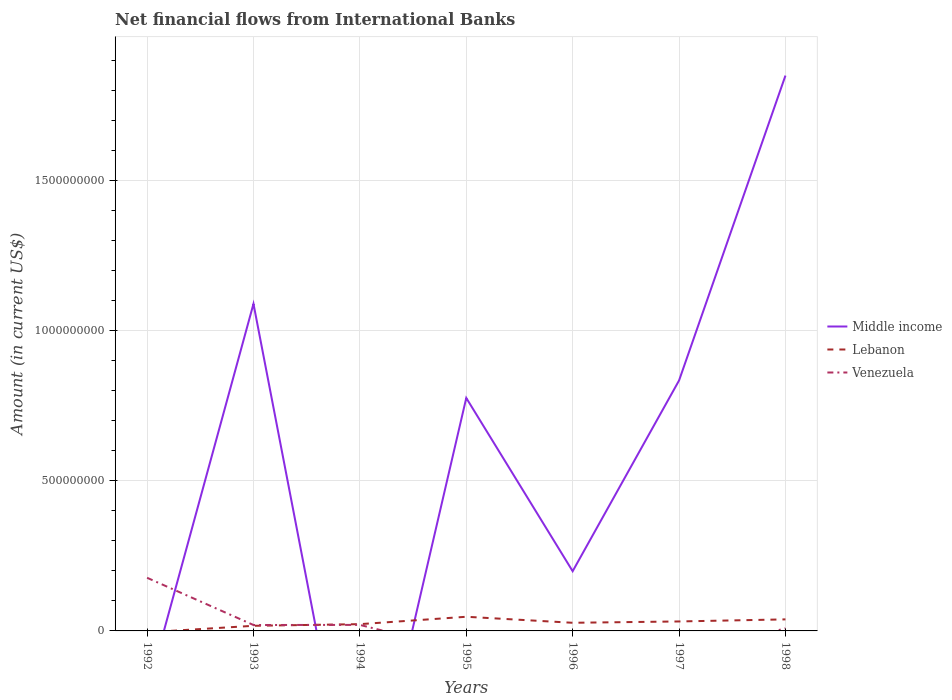Is the number of lines equal to the number of legend labels?
Make the answer very short. No. What is the total net financial aid flows in Venezuela in the graph?
Provide a short and direct response. -4.05e+05. What is the difference between the highest and the second highest net financial aid flows in Middle income?
Provide a short and direct response. 1.85e+09. Does the graph contain grids?
Make the answer very short. Yes. How many legend labels are there?
Provide a succinct answer. 3. How are the legend labels stacked?
Provide a short and direct response. Vertical. What is the title of the graph?
Your answer should be compact. Net financial flows from International Banks. Does "Djibouti" appear as one of the legend labels in the graph?
Offer a terse response. No. What is the label or title of the X-axis?
Make the answer very short. Years. What is the label or title of the Y-axis?
Your response must be concise. Amount (in current US$). What is the Amount (in current US$) in Venezuela in 1992?
Keep it short and to the point. 1.77e+08. What is the Amount (in current US$) of Middle income in 1993?
Make the answer very short. 1.09e+09. What is the Amount (in current US$) of Lebanon in 1993?
Your response must be concise. 1.70e+07. What is the Amount (in current US$) in Venezuela in 1993?
Keep it short and to the point. 1.97e+07. What is the Amount (in current US$) in Lebanon in 1994?
Your response must be concise. 2.25e+07. What is the Amount (in current US$) in Venezuela in 1994?
Provide a succinct answer. 2.01e+07. What is the Amount (in current US$) of Middle income in 1995?
Give a very brief answer. 7.75e+08. What is the Amount (in current US$) of Lebanon in 1995?
Provide a short and direct response. 4.71e+07. What is the Amount (in current US$) in Middle income in 1996?
Keep it short and to the point. 1.99e+08. What is the Amount (in current US$) of Lebanon in 1996?
Offer a very short reply. 2.71e+07. What is the Amount (in current US$) in Venezuela in 1996?
Keep it short and to the point. 0. What is the Amount (in current US$) in Middle income in 1997?
Your answer should be compact. 8.34e+08. What is the Amount (in current US$) of Lebanon in 1997?
Offer a terse response. 3.15e+07. What is the Amount (in current US$) of Middle income in 1998?
Provide a succinct answer. 1.85e+09. What is the Amount (in current US$) of Lebanon in 1998?
Provide a short and direct response. 3.84e+07. What is the Amount (in current US$) of Venezuela in 1998?
Your response must be concise. 8.53e+06. Across all years, what is the maximum Amount (in current US$) of Middle income?
Your answer should be very brief. 1.85e+09. Across all years, what is the maximum Amount (in current US$) of Lebanon?
Offer a very short reply. 4.71e+07. Across all years, what is the maximum Amount (in current US$) of Venezuela?
Provide a succinct answer. 1.77e+08. Across all years, what is the minimum Amount (in current US$) in Lebanon?
Offer a very short reply. 0. Across all years, what is the minimum Amount (in current US$) in Venezuela?
Provide a short and direct response. 0. What is the total Amount (in current US$) of Middle income in the graph?
Provide a succinct answer. 4.74e+09. What is the total Amount (in current US$) in Lebanon in the graph?
Make the answer very short. 1.84e+08. What is the total Amount (in current US$) of Venezuela in the graph?
Your answer should be very brief. 2.25e+08. What is the difference between the Amount (in current US$) of Venezuela in 1992 and that in 1993?
Keep it short and to the point. 1.57e+08. What is the difference between the Amount (in current US$) in Venezuela in 1992 and that in 1994?
Your answer should be compact. 1.57e+08. What is the difference between the Amount (in current US$) of Venezuela in 1992 and that in 1998?
Your answer should be very brief. 1.68e+08. What is the difference between the Amount (in current US$) of Lebanon in 1993 and that in 1994?
Provide a short and direct response. -5.49e+06. What is the difference between the Amount (in current US$) in Venezuela in 1993 and that in 1994?
Your answer should be compact. -4.05e+05. What is the difference between the Amount (in current US$) of Middle income in 1993 and that in 1995?
Offer a very short reply. 3.13e+08. What is the difference between the Amount (in current US$) of Lebanon in 1993 and that in 1995?
Your answer should be compact. -3.01e+07. What is the difference between the Amount (in current US$) in Middle income in 1993 and that in 1996?
Your response must be concise. 8.90e+08. What is the difference between the Amount (in current US$) in Lebanon in 1993 and that in 1996?
Ensure brevity in your answer.  -1.00e+07. What is the difference between the Amount (in current US$) of Middle income in 1993 and that in 1997?
Offer a terse response. 2.55e+08. What is the difference between the Amount (in current US$) of Lebanon in 1993 and that in 1997?
Provide a succinct answer. -1.45e+07. What is the difference between the Amount (in current US$) in Middle income in 1993 and that in 1998?
Your answer should be very brief. -7.60e+08. What is the difference between the Amount (in current US$) of Lebanon in 1993 and that in 1998?
Make the answer very short. -2.14e+07. What is the difference between the Amount (in current US$) of Venezuela in 1993 and that in 1998?
Your response must be concise. 1.11e+07. What is the difference between the Amount (in current US$) of Lebanon in 1994 and that in 1995?
Offer a very short reply. -2.46e+07. What is the difference between the Amount (in current US$) of Lebanon in 1994 and that in 1996?
Provide a succinct answer. -4.54e+06. What is the difference between the Amount (in current US$) of Lebanon in 1994 and that in 1997?
Ensure brevity in your answer.  -8.98e+06. What is the difference between the Amount (in current US$) in Lebanon in 1994 and that in 1998?
Offer a terse response. -1.59e+07. What is the difference between the Amount (in current US$) of Venezuela in 1994 and that in 1998?
Offer a terse response. 1.15e+07. What is the difference between the Amount (in current US$) in Middle income in 1995 and that in 1996?
Keep it short and to the point. 5.77e+08. What is the difference between the Amount (in current US$) of Lebanon in 1995 and that in 1996?
Offer a terse response. 2.00e+07. What is the difference between the Amount (in current US$) of Middle income in 1995 and that in 1997?
Ensure brevity in your answer.  -5.82e+07. What is the difference between the Amount (in current US$) of Lebanon in 1995 and that in 1997?
Your response must be concise. 1.56e+07. What is the difference between the Amount (in current US$) in Middle income in 1995 and that in 1998?
Offer a very short reply. -1.07e+09. What is the difference between the Amount (in current US$) of Lebanon in 1995 and that in 1998?
Make the answer very short. 8.68e+06. What is the difference between the Amount (in current US$) of Middle income in 1996 and that in 1997?
Provide a succinct answer. -6.35e+08. What is the difference between the Amount (in current US$) in Lebanon in 1996 and that in 1997?
Your answer should be compact. -4.43e+06. What is the difference between the Amount (in current US$) of Middle income in 1996 and that in 1998?
Ensure brevity in your answer.  -1.65e+09. What is the difference between the Amount (in current US$) in Lebanon in 1996 and that in 1998?
Provide a short and direct response. -1.14e+07. What is the difference between the Amount (in current US$) of Middle income in 1997 and that in 1998?
Provide a succinct answer. -1.01e+09. What is the difference between the Amount (in current US$) in Lebanon in 1997 and that in 1998?
Keep it short and to the point. -6.92e+06. What is the difference between the Amount (in current US$) of Middle income in 1993 and the Amount (in current US$) of Lebanon in 1994?
Your response must be concise. 1.07e+09. What is the difference between the Amount (in current US$) of Middle income in 1993 and the Amount (in current US$) of Venezuela in 1994?
Your answer should be compact. 1.07e+09. What is the difference between the Amount (in current US$) in Lebanon in 1993 and the Amount (in current US$) in Venezuela in 1994?
Offer a terse response. -3.03e+06. What is the difference between the Amount (in current US$) of Middle income in 1993 and the Amount (in current US$) of Lebanon in 1995?
Your answer should be very brief. 1.04e+09. What is the difference between the Amount (in current US$) in Middle income in 1993 and the Amount (in current US$) in Lebanon in 1996?
Give a very brief answer. 1.06e+09. What is the difference between the Amount (in current US$) in Middle income in 1993 and the Amount (in current US$) in Lebanon in 1997?
Give a very brief answer. 1.06e+09. What is the difference between the Amount (in current US$) of Middle income in 1993 and the Amount (in current US$) of Lebanon in 1998?
Give a very brief answer. 1.05e+09. What is the difference between the Amount (in current US$) of Middle income in 1993 and the Amount (in current US$) of Venezuela in 1998?
Keep it short and to the point. 1.08e+09. What is the difference between the Amount (in current US$) of Lebanon in 1993 and the Amount (in current US$) of Venezuela in 1998?
Your answer should be compact. 8.52e+06. What is the difference between the Amount (in current US$) of Lebanon in 1994 and the Amount (in current US$) of Venezuela in 1998?
Your response must be concise. 1.40e+07. What is the difference between the Amount (in current US$) of Middle income in 1995 and the Amount (in current US$) of Lebanon in 1996?
Offer a terse response. 7.48e+08. What is the difference between the Amount (in current US$) in Middle income in 1995 and the Amount (in current US$) in Lebanon in 1997?
Your response must be concise. 7.44e+08. What is the difference between the Amount (in current US$) of Middle income in 1995 and the Amount (in current US$) of Lebanon in 1998?
Your response must be concise. 7.37e+08. What is the difference between the Amount (in current US$) in Middle income in 1995 and the Amount (in current US$) in Venezuela in 1998?
Your answer should be compact. 7.67e+08. What is the difference between the Amount (in current US$) in Lebanon in 1995 and the Amount (in current US$) in Venezuela in 1998?
Give a very brief answer. 3.86e+07. What is the difference between the Amount (in current US$) in Middle income in 1996 and the Amount (in current US$) in Lebanon in 1997?
Your answer should be very brief. 1.67e+08. What is the difference between the Amount (in current US$) of Middle income in 1996 and the Amount (in current US$) of Lebanon in 1998?
Offer a very short reply. 1.60e+08. What is the difference between the Amount (in current US$) in Middle income in 1996 and the Amount (in current US$) in Venezuela in 1998?
Give a very brief answer. 1.90e+08. What is the difference between the Amount (in current US$) of Lebanon in 1996 and the Amount (in current US$) of Venezuela in 1998?
Ensure brevity in your answer.  1.86e+07. What is the difference between the Amount (in current US$) in Middle income in 1997 and the Amount (in current US$) in Lebanon in 1998?
Keep it short and to the point. 7.95e+08. What is the difference between the Amount (in current US$) of Middle income in 1997 and the Amount (in current US$) of Venezuela in 1998?
Your response must be concise. 8.25e+08. What is the difference between the Amount (in current US$) in Lebanon in 1997 and the Amount (in current US$) in Venezuela in 1998?
Your answer should be compact. 2.30e+07. What is the average Amount (in current US$) in Middle income per year?
Ensure brevity in your answer.  6.78e+08. What is the average Amount (in current US$) in Lebanon per year?
Provide a short and direct response. 2.63e+07. What is the average Amount (in current US$) in Venezuela per year?
Provide a short and direct response. 3.22e+07. In the year 1993, what is the difference between the Amount (in current US$) in Middle income and Amount (in current US$) in Lebanon?
Provide a short and direct response. 1.07e+09. In the year 1993, what is the difference between the Amount (in current US$) in Middle income and Amount (in current US$) in Venezuela?
Give a very brief answer. 1.07e+09. In the year 1993, what is the difference between the Amount (in current US$) of Lebanon and Amount (in current US$) of Venezuela?
Offer a very short reply. -2.62e+06. In the year 1994, what is the difference between the Amount (in current US$) of Lebanon and Amount (in current US$) of Venezuela?
Keep it short and to the point. 2.46e+06. In the year 1995, what is the difference between the Amount (in current US$) in Middle income and Amount (in current US$) in Lebanon?
Keep it short and to the point. 7.28e+08. In the year 1996, what is the difference between the Amount (in current US$) of Middle income and Amount (in current US$) of Lebanon?
Keep it short and to the point. 1.72e+08. In the year 1997, what is the difference between the Amount (in current US$) in Middle income and Amount (in current US$) in Lebanon?
Your response must be concise. 8.02e+08. In the year 1998, what is the difference between the Amount (in current US$) of Middle income and Amount (in current US$) of Lebanon?
Provide a succinct answer. 1.81e+09. In the year 1998, what is the difference between the Amount (in current US$) of Middle income and Amount (in current US$) of Venezuela?
Your answer should be compact. 1.84e+09. In the year 1998, what is the difference between the Amount (in current US$) in Lebanon and Amount (in current US$) in Venezuela?
Offer a very short reply. 2.99e+07. What is the ratio of the Amount (in current US$) of Venezuela in 1992 to that in 1993?
Offer a terse response. 8.99. What is the ratio of the Amount (in current US$) of Venezuela in 1992 to that in 1994?
Keep it short and to the point. 8.81. What is the ratio of the Amount (in current US$) in Venezuela in 1992 to that in 1998?
Provide a short and direct response. 20.73. What is the ratio of the Amount (in current US$) of Lebanon in 1993 to that in 1994?
Offer a terse response. 0.76. What is the ratio of the Amount (in current US$) in Venezuela in 1993 to that in 1994?
Your response must be concise. 0.98. What is the ratio of the Amount (in current US$) in Middle income in 1993 to that in 1995?
Offer a very short reply. 1.4. What is the ratio of the Amount (in current US$) in Lebanon in 1993 to that in 1995?
Make the answer very short. 0.36. What is the ratio of the Amount (in current US$) of Middle income in 1993 to that in 1996?
Offer a terse response. 5.48. What is the ratio of the Amount (in current US$) in Lebanon in 1993 to that in 1996?
Your answer should be very brief. 0.63. What is the ratio of the Amount (in current US$) of Middle income in 1993 to that in 1997?
Give a very brief answer. 1.31. What is the ratio of the Amount (in current US$) of Lebanon in 1993 to that in 1997?
Offer a very short reply. 0.54. What is the ratio of the Amount (in current US$) of Middle income in 1993 to that in 1998?
Offer a terse response. 0.59. What is the ratio of the Amount (in current US$) of Lebanon in 1993 to that in 1998?
Keep it short and to the point. 0.44. What is the ratio of the Amount (in current US$) in Venezuela in 1993 to that in 1998?
Provide a short and direct response. 2.31. What is the ratio of the Amount (in current US$) in Lebanon in 1994 to that in 1995?
Give a very brief answer. 0.48. What is the ratio of the Amount (in current US$) of Lebanon in 1994 to that in 1996?
Offer a terse response. 0.83. What is the ratio of the Amount (in current US$) of Lebanon in 1994 to that in 1997?
Give a very brief answer. 0.72. What is the ratio of the Amount (in current US$) in Lebanon in 1994 to that in 1998?
Ensure brevity in your answer.  0.59. What is the ratio of the Amount (in current US$) in Venezuela in 1994 to that in 1998?
Ensure brevity in your answer.  2.35. What is the ratio of the Amount (in current US$) of Middle income in 1995 to that in 1996?
Your answer should be very brief. 3.9. What is the ratio of the Amount (in current US$) of Lebanon in 1995 to that in 1996?
Ensure brevity in your answer.  1.74. What is the ratio of the Amount (in current US$) of Middle income in 1995 to that in 1997?
Make the answer very short. 0.93. What is the ratio of the Amount (in current US$) of Lebanon in 1995 to that in 1997?
Provide a short and direct response. 1.5. What is the ratio of the Amount (in current US$) in Middle income in 1995 to that in 1998?
Offer a very short reply. 0.42. What is the ratio of the Amount (in current US$) of Lebanon in 1995 to that in 1998?
Offer a very short reply. 1.23. What is the ratio of the Amount (in current US$) in Middle income in 1996 to that in 1997?
Your answer should be compact. 0.24. What is the ratio of the Amount (in current US$) in Lebanon in 1996 to that in 1997?
Ensure brevity in your answer.  0.86. What is the ratio of the Amount (in current US$) of Middle income in 1996 to that in 1998?
Keep it short and to the point. 0.11. What is the ratio of the Amount (in current US$) of Lebanon in 1996 to that in 1998?
Give a very brief answer. 0.7. What is the ratio of the Amount (in current US$) of Middle income in 1997 to that in 1998?
Your answer should be very brief. 0.45. What is the ratio of the Amount (in current US$) in Lebanon in 1997 to that in 1998?
Your response must be concise. 0.82. What is the difference between the highest and the second highest Amount (in current US$) of Middle income?
Provide a short and direct response. 7.60e+08. What is the difference between the highest and the second highest Amount (in current US$) of Lebanon?
Your response must be concise. 8.68e+06. What is the difference between the highest and the second highest Amount (in current US$) of Venezuela?
Provide a short and direct response. 1.57e+08. What is the difference between the highest and the lowest Amount (in current US$) in Middle income?
Offer a terse response. 1.85e+09. What is the difference between the highest and the lowest Amount (in current US$) of Lebanon?
Give a very brief answer. 4.71e+07. What is the difference between the highest and the lowest Amount (in current US$) of Venezuela?
Offer a very short reply. 1.77e+08. 